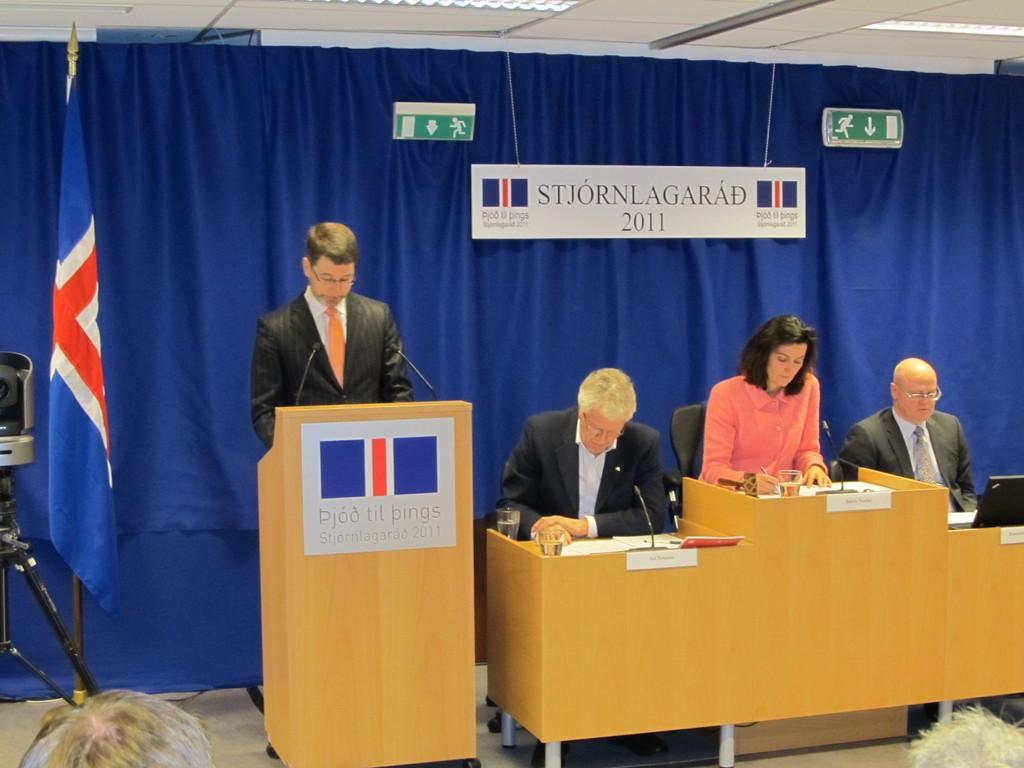<image>
Describe the image concisely. People standing and sitting in front of a sign which says STJORNLAGARAD. 